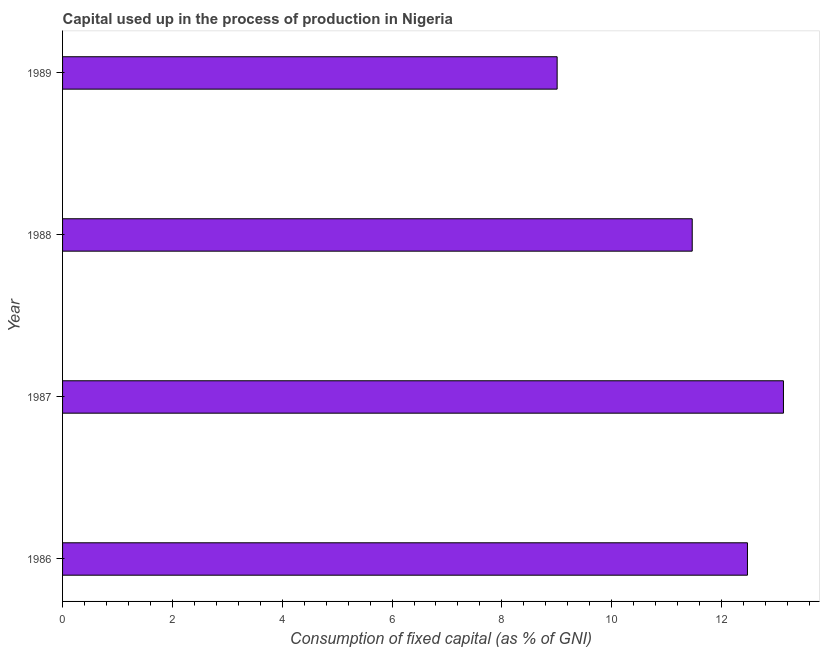Does the graph contain any zero values?
Your answer should be compact. No. Does the graph contain grids?
Offer a very short reply. No. What is the title of the graph?
Provide a succinct answer. Capital used up in the process of production in Nigeria. What is the label or title of the X-axis?
Keep it short and to the point. Consumption of fixed capital (as % of GNI). What is the label or title of the Y-axis?
Offer a very short reply. Year. What is the consumption of fixed capital in 1989?
Offer a terse response. 9.01. Across all years, what is the maximum consumption of fixed capital?
Your response must be concise. 13.13. Across all years, what is the minimum consumption of fixed capital?
Offer a terse response. 9.01. In which year was the consumption of fixed capital maximum?
Keep it short and to the point. 1987. In which year was the consumption of fixed capital minimum?
Provide a succinct answer. 1989. What is the sum of the consumption of fixed capital?
Offer a very short reply. 46.07. What is the difference between the consumption of fixed capital in 1986 and 1989?
Your response must be concise. 3.47. What is the average consumption of fixed capital per year?
Make the answer very short. 11.52. What is the median consumption of fixed capital?
Your answer should be compact. 11.97. In how many years, is the consumption of fixed capital greater than 6.8 %?
Give a very brief answer. 4. What is the ratio of the consumption of fixed capital in 1987 to that in 1988?
Provide a succinct answer. 1.15. Is the consumption of fixed capital in 1986 less than that in 1989?
Your answer should be compact. No. What is the difference between the highest and the second highest consumption of fixed capital?
Offer a terse response. 0.66. Is the sum of the consumption of fixed capital in 1987 and 1989 greater than the maximum consumption of fixed capital across all years?
Offer a very short reply. Yes. What is the difference between the highest and the lowest consumption of fixed capital?
Offer a terse response. 4.12. Are all the bars in the graph horizontal?
Give a very brief answer. Yes. What is the Consumption of fixed capital (as % of GNI) of 1986?
Provide a short and direct response. 12.47. What is the Consumption of fixed capital (as % of GNI) in 1987?
Provide a short and direct response. 13.13. What is the Consumption of fixed capital (as % of GNI) of 1988?
Your response must be concise. 11.47. What is the Consumption of fixed capital (as % of GNI) in 1989?
Provide a short and direct response. 9.01. What is the difference between the Consumption of fixed capital (as % of GNI) in 1986 and 1987?
Keep it short and to the point. -0.66. What is the difference between the Consumption of fixed capital (as % of GNI) in 1986 and 1988?
Provide a short and direct response. 1.01. What is the difference between the Consumption of fixed capital (as % of GNI) in 1986 and 1989?
Your answer should be very brief. 3.47. What is the difference between the Consumption of fixed capital (as % of GNI) in 1987 and 1988?
Your answer should be very brief. 1.66. What is the difference between the Consumption of fixed capital (as % of GNI) in 1987 and 1989?
Ensure brevity in your answer.  4.12. What is the difference between the Consumption of fixed capital (as % of GNI) in 1988 and 1989?
Your response must be concise. 2.46. What is the ratio of the Consumption of fixed capital (as % of GNI) in 1986 to that in 1988?
Offer a terse response. 1.09. What is the ratio of the Consumption of fixed capital (as % of GNI) in 1986 to that in 1989?
Give a very brief answer. 1.39. What is the ratio of the Consumption of fixed capital (as % of GNI) in 1987 to that in 1988?
Offer a terse response. 1.15. What is the ratio of the Consumption of fixed capital (as % of GNI) in 1987 to that in 1989?
Provide a succinct answer. 1.46. What is the ratio of the Consumption of fixed capital (as % of GNI) in 1988 to that in 1989?
Offer a terse response. 1.27. 